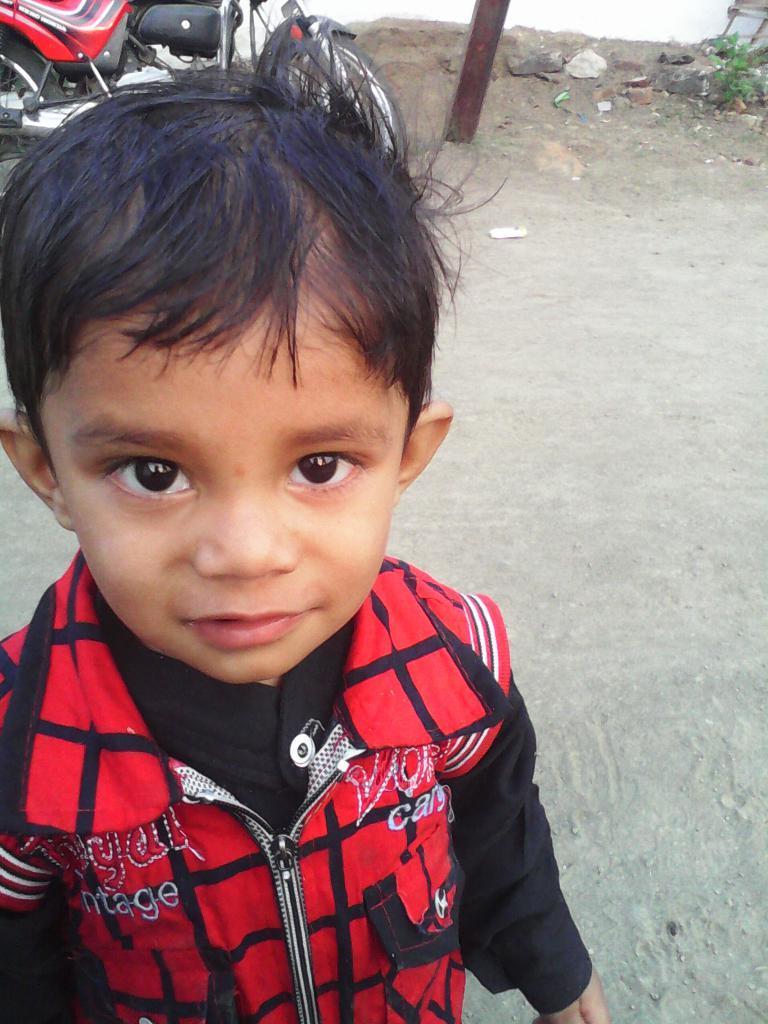Please provide a concise description of this image. In the image we can see a child wearing clothes and the child is smiling. Behind the child we can see two wheeler, pole, sand and stones. Here we can see the road and leaves. 